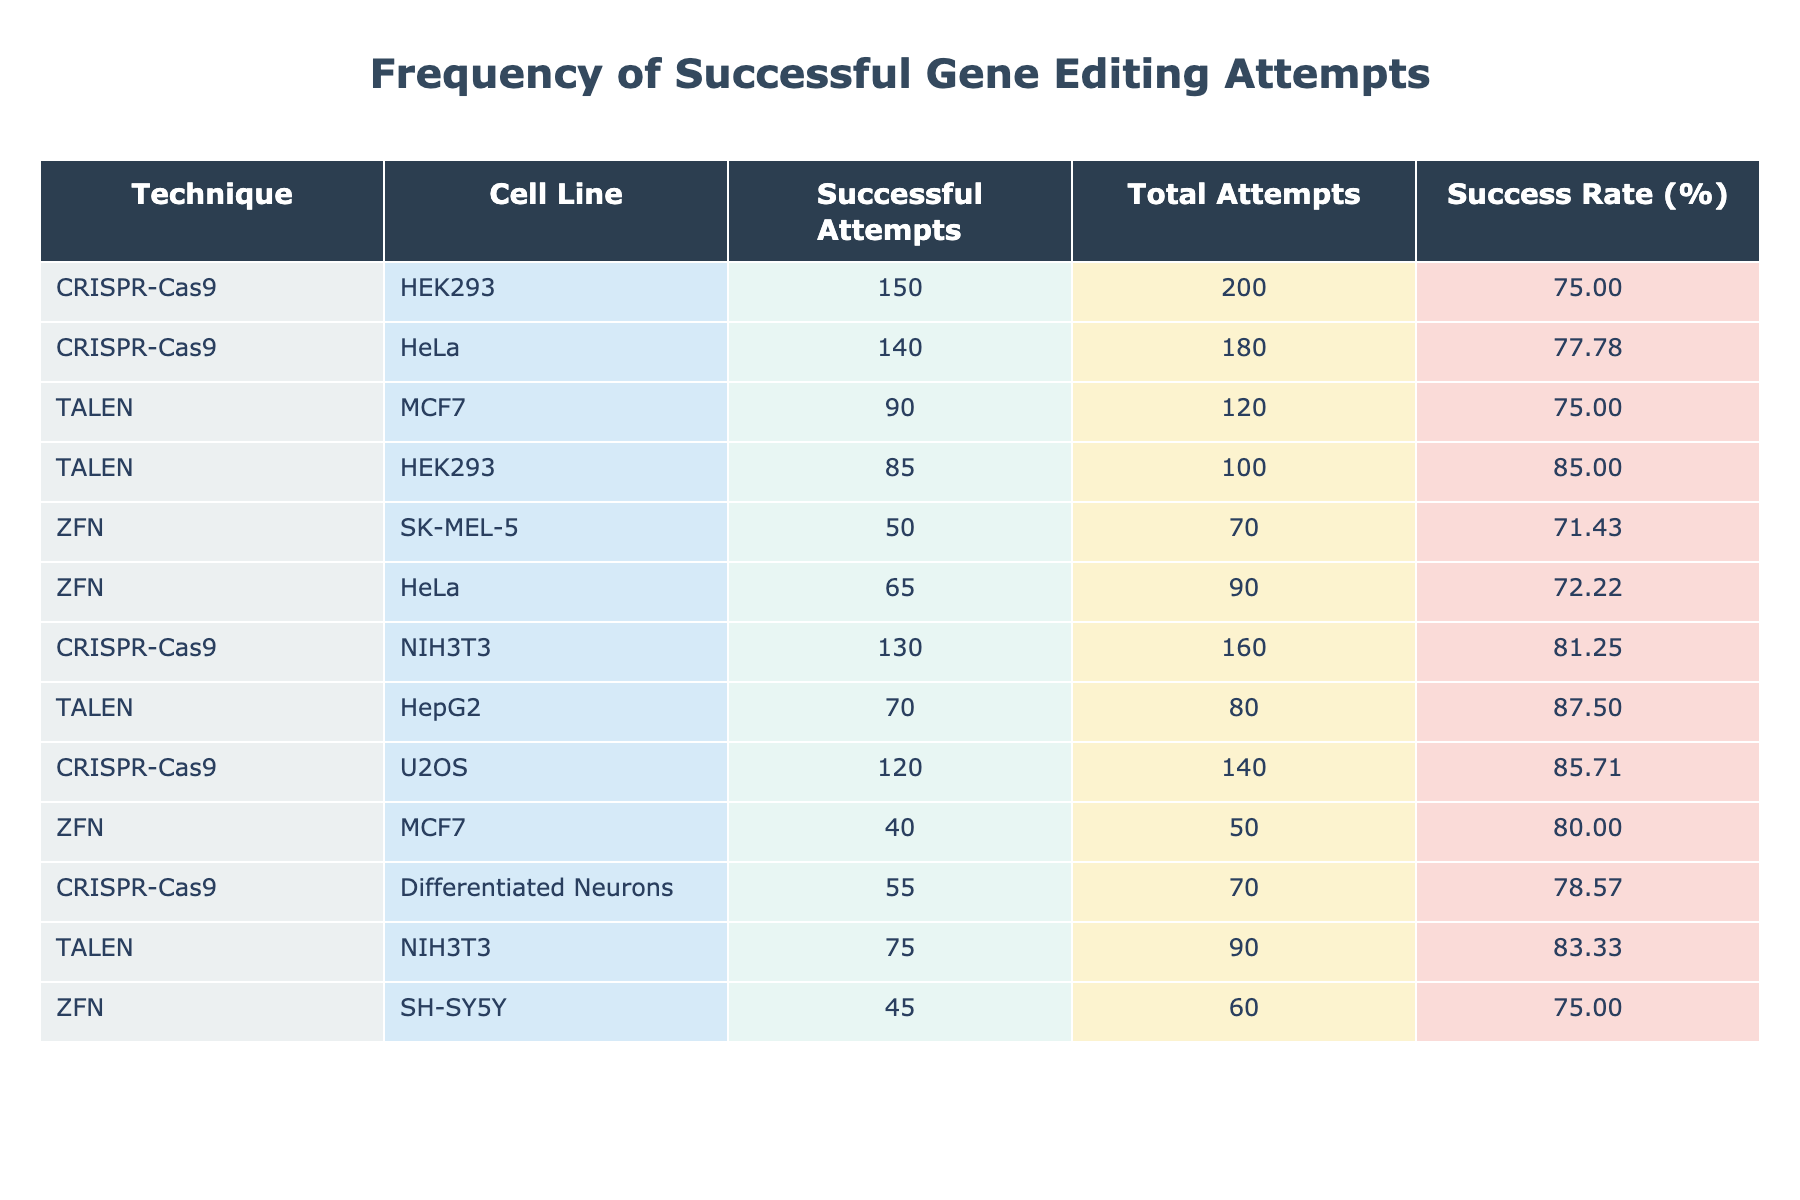What is the success rate for CRISPR-Cas9 in the HeLa cell line? The success rate is calculated by dividing the successful attempts by the total attempts and then multiplying by 100. For HeLa, the successful attempts are 140 and the total attempts are 180. Therefore, the success rate is (140 / 180) * 100 = 77.78.
Answer: 77.78 Which cell line has the highest number of successful gene editing attempts using TALEN? Looking at the TALEN technique, the cell line with the highest successful attempts is MCF7 with 90 successful attempts.
Answer: MCF7 Is the total number of attempts for ZFN in HeLa greater than the total attempts for ZFN in SK-MEL-5? For ZFN in HeLa, the total attempts are 90, and for SK-MEL-5, the total attempts are 70. Since 90 is greater than 70, the statement is true.
Answer: Yes How many total attempts were made using the CRISPR-Cas9 technique across all cell lines listed? To find the total attempts for CRISPR-Cas9, we need to sum the total attempts for each cell line where CRISPR-Cas9 was used: 200 (HEK293) + 180 (HeLa) + 160 (NIH3T3) + 140 (U2OS) + 70 (Differentiated Neurons) = 850.
Answer: 850 What is the average success rate of all techniques combined? First, calculate the success rates for each row as follows: CRISPR-Cas9 (75.00, 77.78, 81.25, 85.71, 78.57), TALEN (75.00, 85.00, 87.50), and ZFN (71.43, 72.22, 66.67). The average of these rates is (75.00 + 77.78 + 81.25 + 85.71 + 78.57 + 75.00 + 87.50 + 71.43 + 72.22 + 66.67) / 10, which equals 76.94.
Answer: 76.94 Is the success rate for TALEN in NIH3T3 greater than 75%? The success rate for TALEN in NIH3T3 is calculated as (75 / 90) * 100 = 83.33. Since 83.33 is indeed greater than 75, the statement is true.
Answer: Yes Which technique had the least successful attempts across all cell lines and what was the number? Looking at the successful attempts across all techniques, the lowest number comes from ZFN in MCF7, which has 40 successful attempts.
Answer: 40 If we compare the success rates of CRISPR-Cas9 and TALEN in MCF7, which technique performs better? For MCF7, CRISPR-Cas9 has a success rate of (150/200)*100 = 75.00, while TALEN has a success rate of (90/120)*100 = 75.00. Both have the same success rate.
Answer: Both are equal 